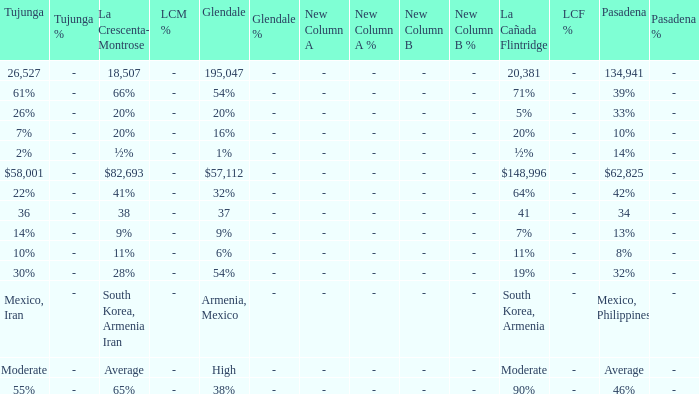What is the figure for La Crescenta-Montrose when Gelndale is $57,112? $82,693. 